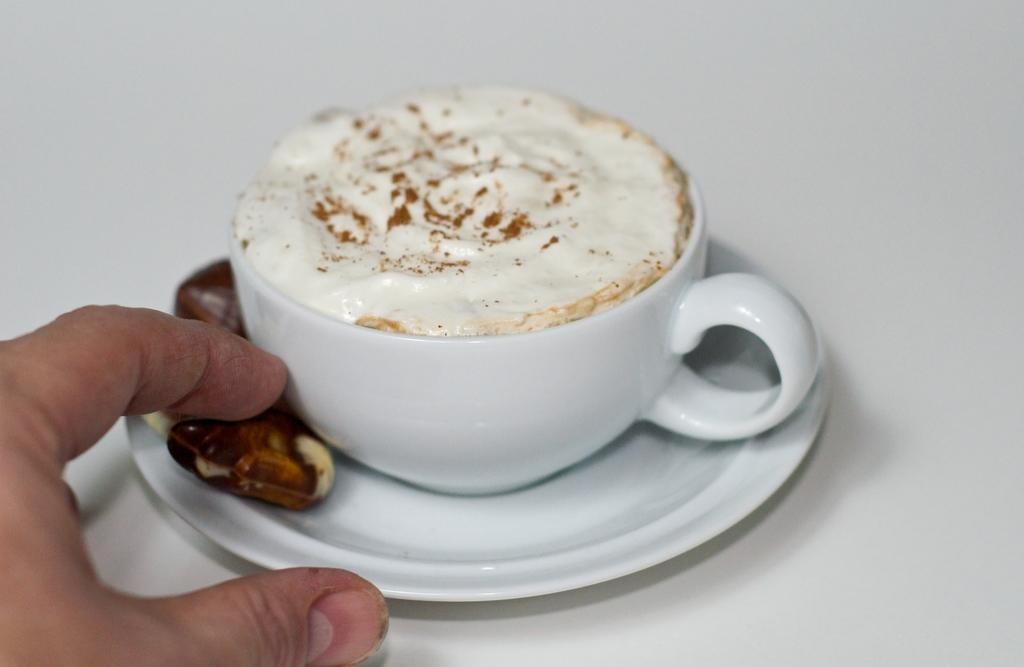What can be seen in the image that belongs to a person? There is a person's hand in the image. What is the person's hand holding or touching? The person's hand is holding a saucer. What is on the saucer? There is a cup with coffee and other food on the saucer. Can you see a banana on the saucer in the image? There is no banana present on the saucer in the image. Is there a frog sitting on the cup in the image? There is no frog present in the image. 